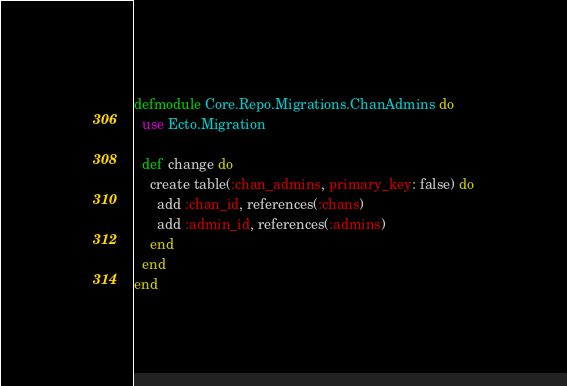Convert code to text. <code><loc_0><loc_0><loc_500><loc_500><_Elixir_>defmodule Core.Repo.Migrations.ChanAdmins do
  use Ecto.Migration

  def change do
    create table(:chan_admins, primary_key: false) do
      add :chan_id, references(:chans)
      add :admin_id, references(:admins)
    end
  end
end
</code> 